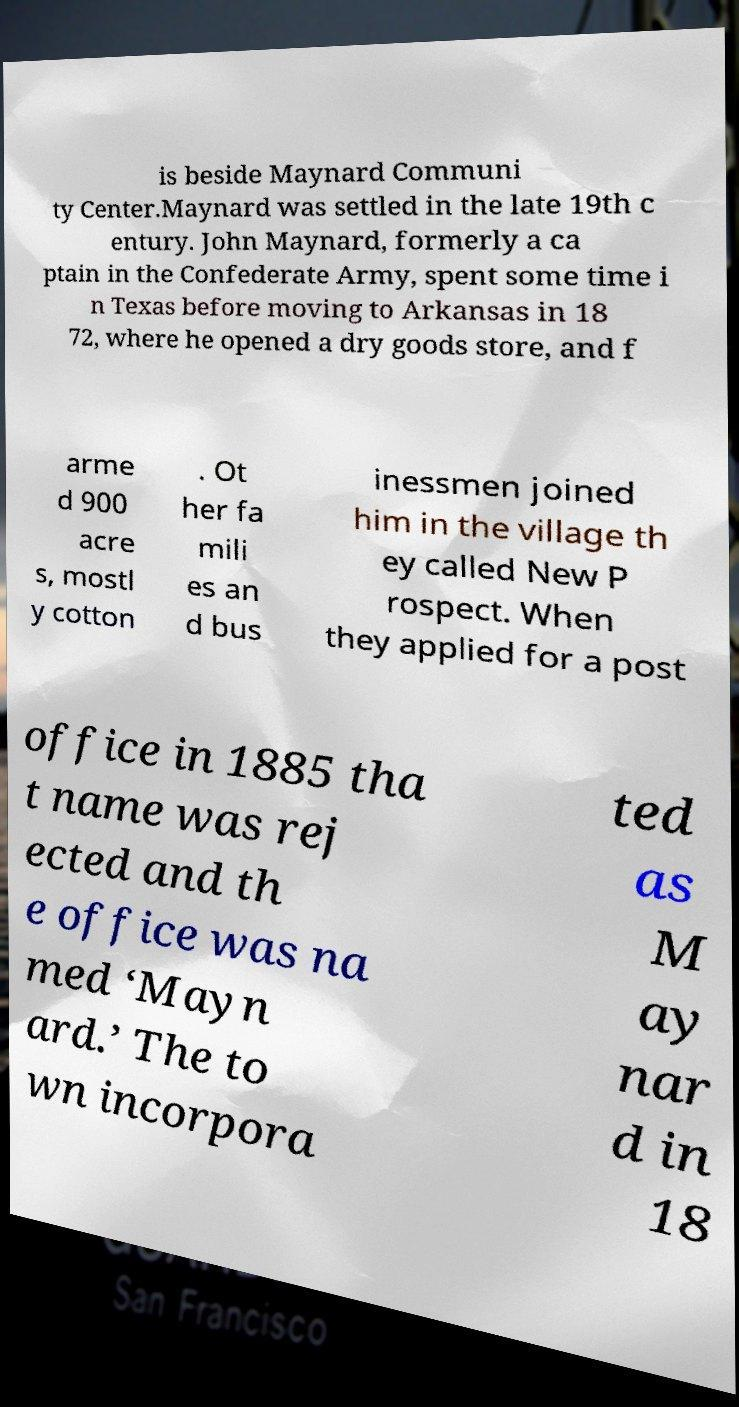There's text embedded in this image that I need extracted. Can you transcribe it verbatim? is beside Maynard Communi ty Center.Maynard was settled in the late 19th c entury. John Maynard, formerly a ca ptain in the Confederate Army, spent some time i n Texas before moving to Arkansas in 18 72, where he opened a dry goods store, and f arme d 900 acre s, mostl y cotton . Ot her fa mili es an d bus inessmen joined him in the village th ey called New P rospect. When they applied for a post office in 1885 tha t name was rej ected and th e office was na med ‘Mayn ard.’ The to wn incorpora ted as M ay nar d in 18 